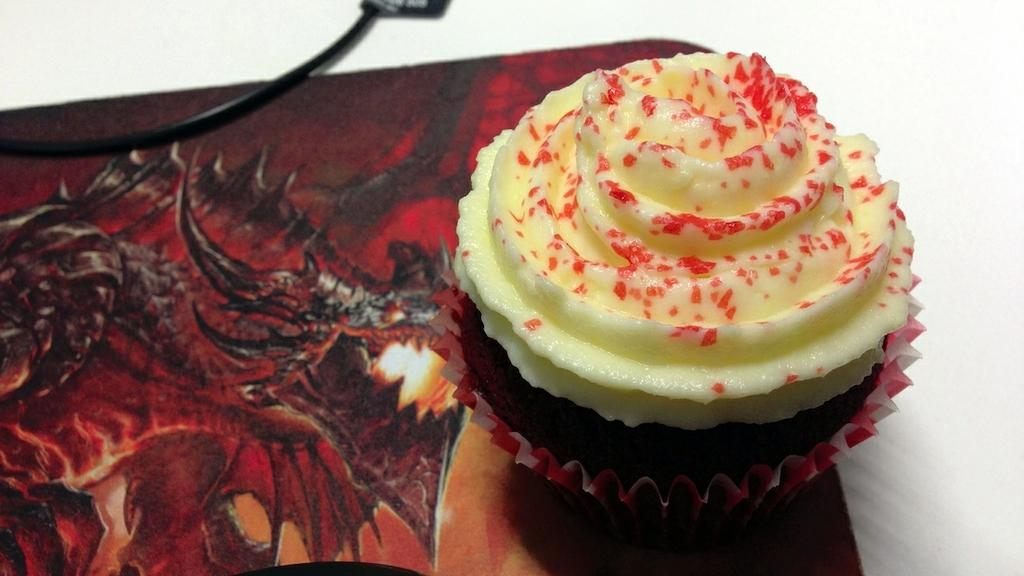What can be seen running through the image? There is a cable in the image. What type of food is depicted in the image? There is a cupcake with mold paper in the image. What kind of image is on an object in the image? There is a picture of a dragon on an object in the image. What color is the background of the image? The background of the image is white. What type of knife is used to cut the celery in the image? There is no knife or celery present in the image. How is the honey being used in the image? There is no honey present in the image. 